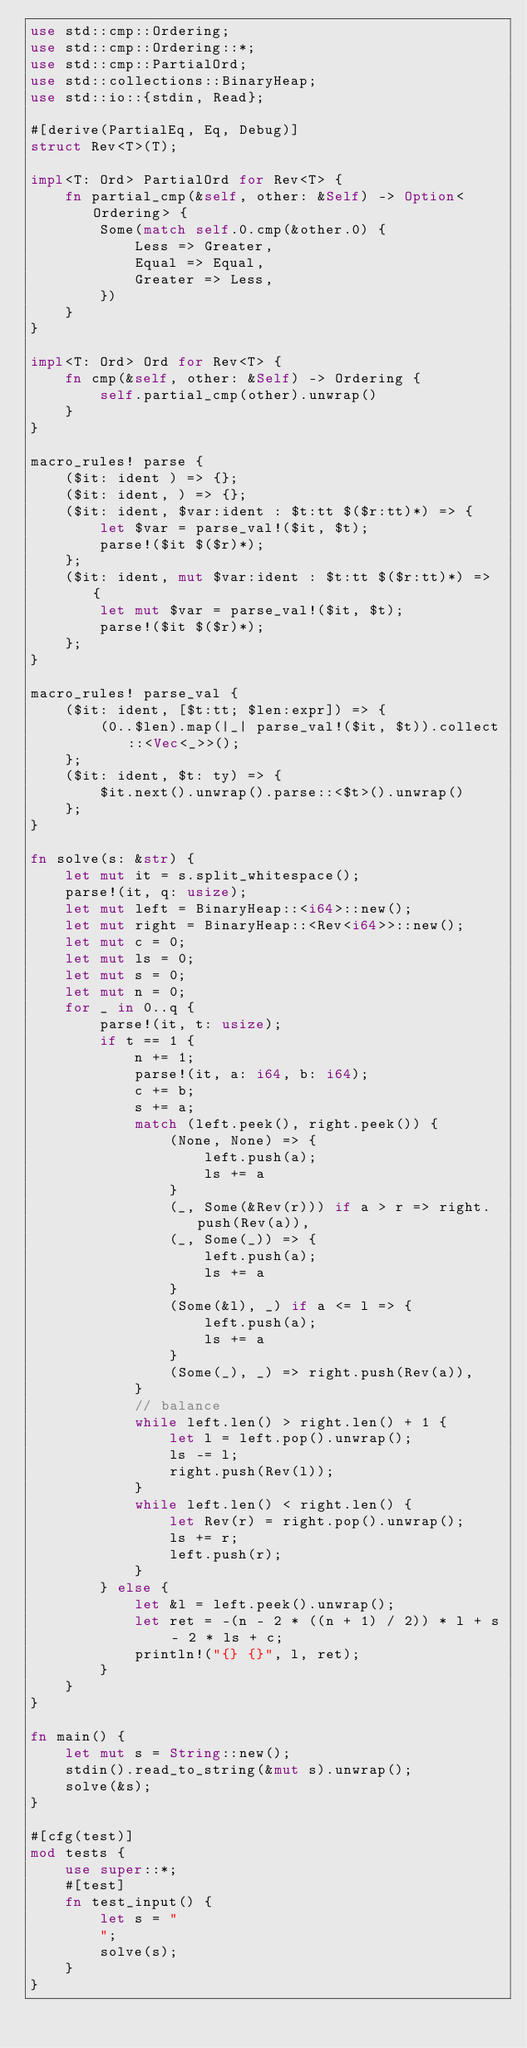Convert code to text. <code><loc_0><loc_0><loc_500><loc_500><_Rust_>use std::cmp::Ordering;
use std::cmp::Ordering::*;
use std::cmp::PartialOrd;
use std::collections::BinaryHeap;
use std::io::{stdin, Read};

#[derive(PartialEq, Eq, Debug)]
struct Rev<T>(T);

impl<T: Ord> PartialOrd for Rev<T> {
    fn partial_cmp(&self, other: &Self) -> Option<Ordering> {
        Some(match self.0.cmp(&other.0) {
            Less => Greater,
            Equal => Equal,
            Greater => Less,
        })
    }
}

impl<T: Ord> Ord for Rev<T> {
    fn cmp(&self, other: &Self) -> Ordering {
        self.partial_cmp(other).unwrap()
    }
}

macro_rules! parse {
    ($it: ident ) => {};
    ($it: ident, ) => {};
    ($it: ident, $var:ident : $t:tt $($r:tt)*) => {
        let $var = parse_val!($it, $t);
        parse!($it $($r)*);
    };
    ($it: ident, mut $var:ident : $t:tt $($r:tt)*) => {
        let mut $var = parse_val!($it, $t);
        parse!($it $($r)*);
    };
}

macro_rules! parse_val {
    ($it: ident, [$t:tt; $len:expr]) => {
        (0..$len).map(|_| parse_val!($it, $t)).collect::<Vec<_>>();
    };
    ($it: ident, $t: ty) => {
        $it.next().unwrap().parse::<$t>().unwrap()
    };
}

fn solve(s: &str) {
    let mut it = s.split_whitespace();
    parse!(it, q: usize);
    let mut left = BinaryHeap::<i64>::new();
    let mut right = BinaryHeap::<Rev<i64>>::new();
    let mut c = 0;
    let mut ls = 0;
    let mut s = 0;
    let mut n = 0;
    for _ in 0..q {
        parse!(it, t: usize);
        if t == 1 {
            n += 1;
            parse!(it, a: i64, b: i64);
            c += b;
            s += a;
            match (left.peek(), right.peek()) {
                (None, None) => {
                    left.push(a);
                    ls += a
                }
                (_, Some(&Rev(r))) if a > r => right.push(Rev(a)),
                (_, Some(_)) => {
                    left.push(a);
                    ls += a
                }
                (Some(&l), _) if a <= l => {
                    left.push(a);
                    ls += a
                }
                (Some(_), _) => right.push(Rev(a)),
            }
            // balance
            while left.len() > right.len() + 1 {
                let l = left.pop().unwrap();
                ls -= l;
                right.push(Rev(l));
            }
            while left.len() < right.len() {
                let Rev(r) = right.pop().unwrap();
                ls += r;
                left.push(r);
            }
        } else {
            let &l = left.peek().unwrap();
            let ret = -(n - 2 * ((n + 1) / 2)) * l + s - 2 * ls + c;
            println!("{} {}", l, ret);
        }
    }
}

fn main() {
    let mut s = String::new();
    stdin().read_to_string(&mut s).unwrap();
    solve(&s);
}

#[cfg(test)]
mod tests {
    use super::*;
    #[test]
    fn test_input() {
        let s = "
        ";
        solve(s);
    }
}
</code> 